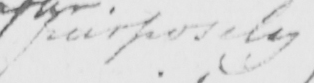Please provide the text content of this handwritten line. purposely 